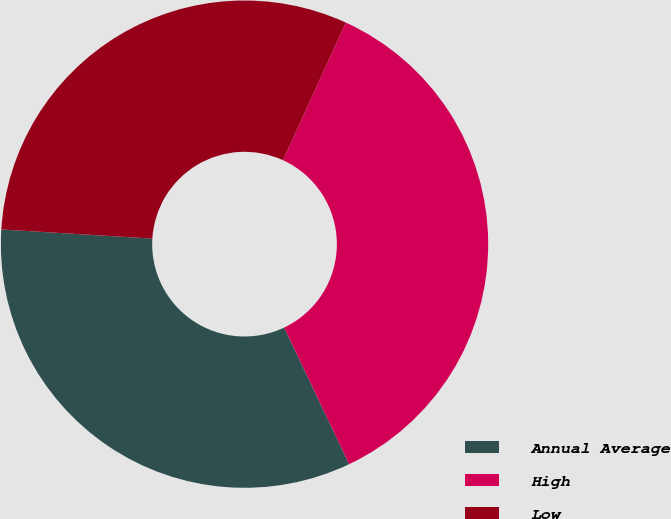<chart> <loc_0><loc_0><loc_500><loc_500><pie_chart><fcel>Annual Average<fcel>High<fcel>Low<nl><fcel>33.02%<fcel>36.11%<fcel>30.86%<nl></chart> 